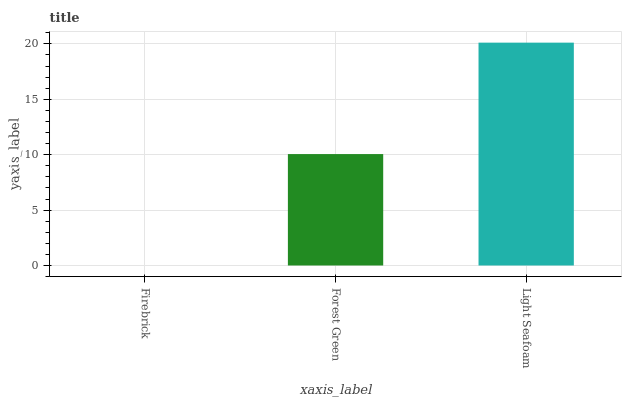Is Firebrick the minimum?
Answer yes or no. Yes. Is Light Seafoam the maximum?
Answer yes or no. Yes. Is Forest Green the minimum?
Answer yes or no. No. Is Forest Green the maximum?
Answer yes or no. No. Is Forest Green greater than Firebrick?
Answer yes or no. Yes. Is Firebrick less than Forest Green?
Answer yes or no. Yes. Is Firebrick greater than Forest Green?
Answer yes or no. No. Is Forest Green less than Firebrick?
Answer yes or no. No. Is Forest Green the high median?
Answer yes or no. Yes. Is Forest Green the low median?
Answer yes or no. Yes. Is Light Seafoam the high median?
Answer yes or no. No. Is Firebrick the low median?
Answer yes or no. No. 